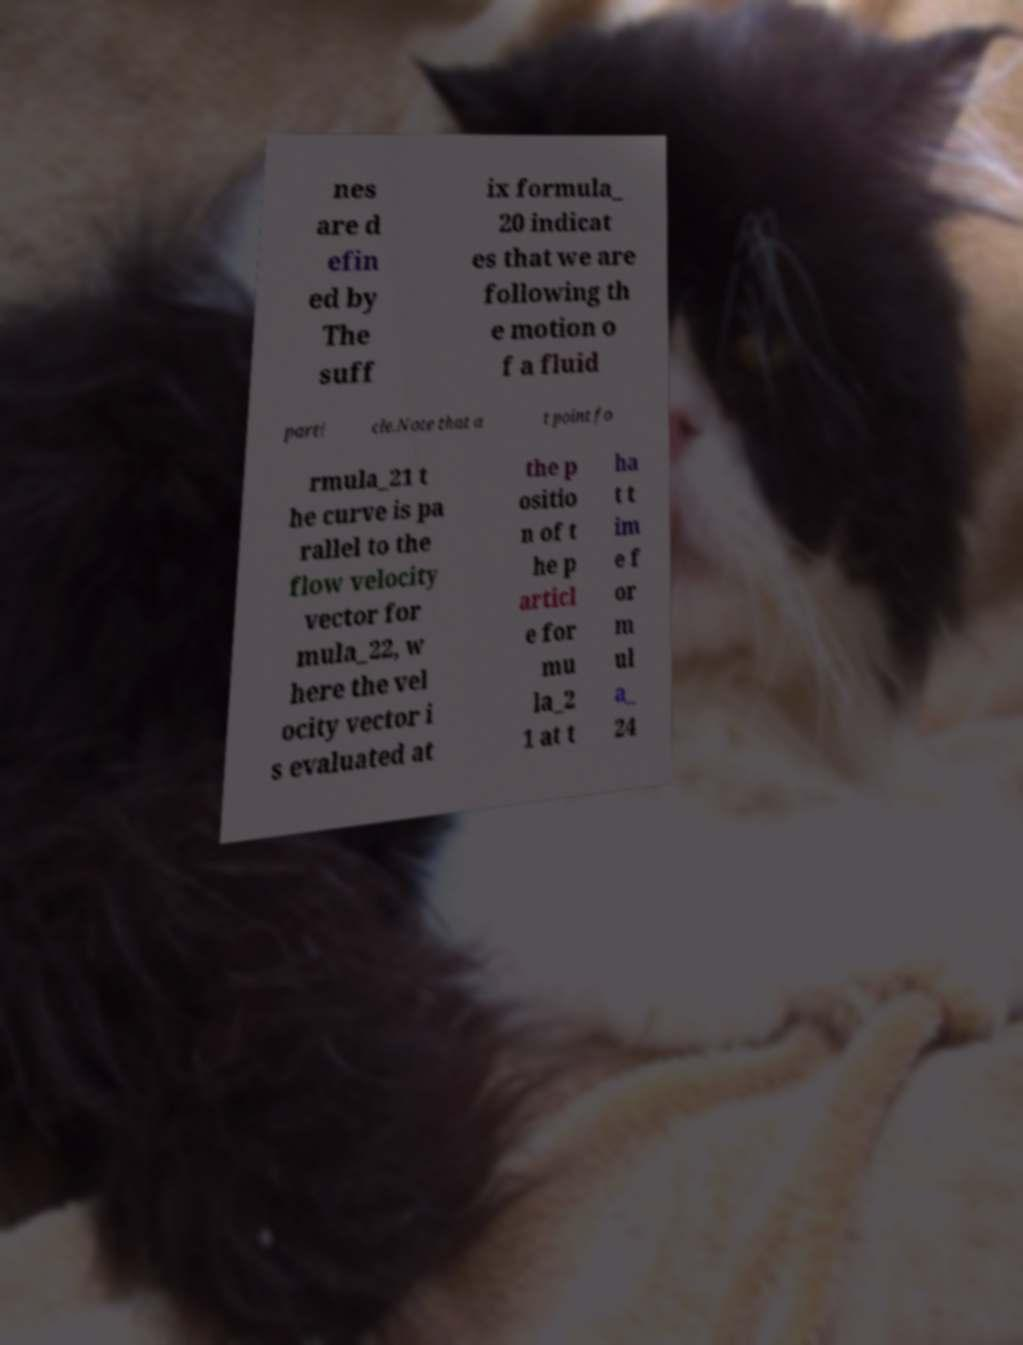For documentation purposes, I need the text within this image transcribed. Could you provide that? nes are d efin ed by The suff ix formula_ 20 indicat es that we are following th e motion o f a fluid parti cle.Note that a t point fo rmula_21 t he curve is pa rallel to the flow velocity vector for mula_22, w here the vel ocity vector i s evaluated at the p ositio n of t he p articl e for mu la_2 1 at t ha t t im e f or m ul a_ 24 